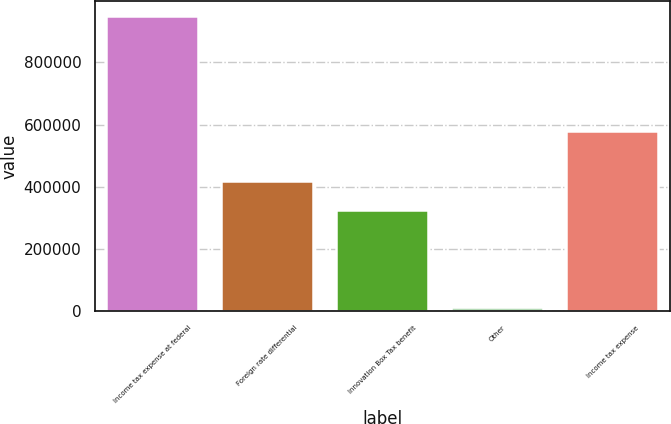Convert chart. <chart><loc_0><loc_0><loc_500><loc_500><bar_chart><fcel>Income tax expense at federal<fcel>Foreign rate differential<fcel>Innovation Box Tax benefit<fcel>Other<fcel>Income tax expense<nl><fcel>949633<fcel>418327<fcel>324633<fcel>12691<fcel>578251<nl></chart> 